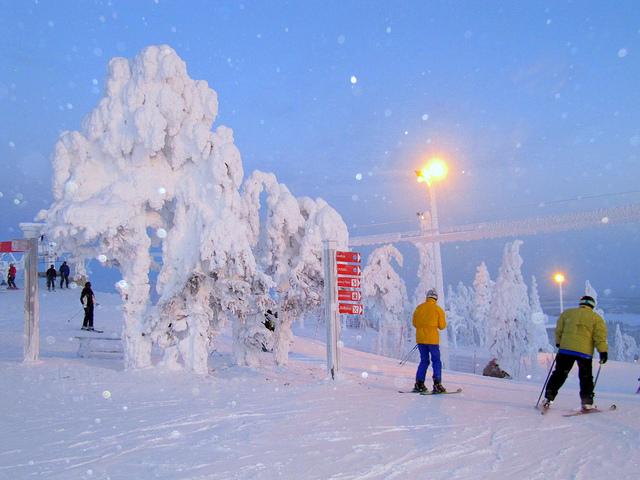Are the skiers facing the camera?
Quick response, please. No. Can you see the sun in this picture?
Answer briefly. No. What color are the signs?
Write a very short answer. Red. 